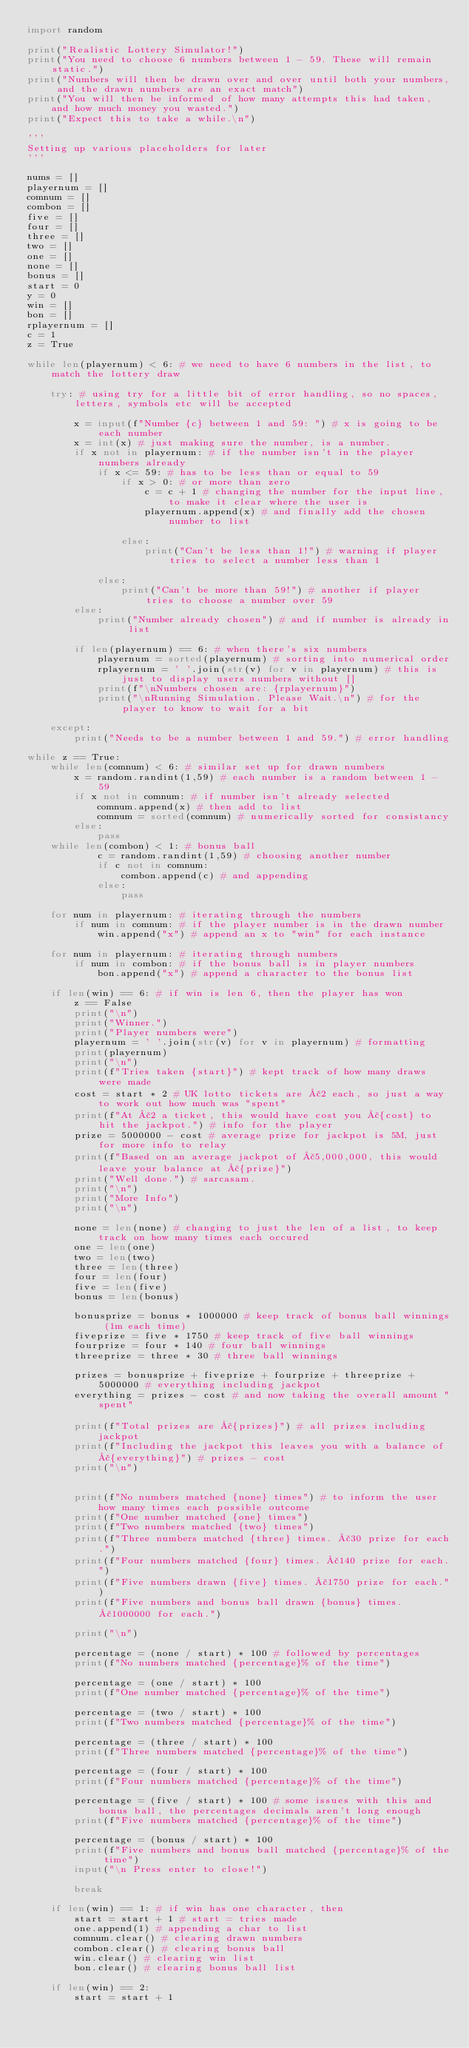<code> <loc_0><loc_0><loc_500><loc_500><_Python_>import random

print("Realistic Lottery Simulator!")
print("You need to choose 6 numbers between 1 - 59. These will remain static.")
print("Numbers will then be drawn over and over until both your numbers, and the drawn numbers are an exact match")
print("You will then be informed of how many attempts this had taken, and how much money you wasted.")
print("Expect this to take a while.\n")

'''
Setting up various placeholders for later
'''

nums = []
playernum = []
comnum = []
combon = []
five = []
four = []
three = []
two = []
one = []
none = []
bonus = []
start = 0
y = 0
win = []
bon = []
rplayernum = []
c = 1
z = True

while len(playernum) < 6: # we need to have 6 numbers in the list, to match the lottery draw
    
    try: # using try for a little bit of error handling, so no spaces, letters, symbols etc will be accepted

        x = input(f"Number {c} between 1 and 59: ") # x is going to be each number
        x = int(x) # just making sure the number, is a number.
        if x not in playernum: # if the number isn't in the player numbers already
            if x <= 59: # has to be less than or equal to 59
                if x > 0: # or more than zero
                    c = c + 1 # changing the number for the input line, to make it clear where the user is
                    playernum.append(x) # and finally add the chosen number to list

                else:
                    print("Can't be less than 1!") # warning if player tries to select a number less than 1

            else:
                print("Can't be more than 59!") # another if player tries to choose a number over 59
        else:
            print("Number already chosen") # and if number is already in list

        if len(playernum) == 6: # when there's six numbers
            playernum = sorted(playernum) # sorting into numerical order
            rplayernum = ' '.join(str(v) for v in playernum) # this is just to display users numbers without []
            print(f"\nNumbers chosen are: {rplayernum}")
            print("\nRunning Simulation. Please Wait.\n") # for the player to know to wait for a bit
            
    except:
        print("Needs to be a number between 1 and 59.") # error handling

while z == True:       
    while len(comnum) < 6: # similar set up for drawn numbers
        x = random.randint(1,59) # each number is a random between 1 - 59
        if x not in comnum: # if number isn't already selected
            comnum.append(x) # then add to list
            comnum = sorted(comnum) # numerically sorted for consistancy
        else:
            pass
    while len(combon) < 1: # bonus ball
            c = random.randint(1,59) # choosing another number
            if c not in comnum:
                combon.append(c) # and appending
            else:
                pass

    for num in playernum: # iterating through the numbers
        if num in comnum: # if the player number is in the drawn number
            win.append("x") # append an x to "win" for each instance
        
    for num in playernum: # iterating through numbers
        if num in combon: # if the bonus ball is in player numbers
            bon.append("x") # append a character to the bonus list
    
    if len(win) == 6: # if win is len 6, then the player has won
        z == False
        print("\n")
        print("Winner.")
        print("Player numbers were")
        playernum = ' '.join(str(v) for v in playernum) # formatting
        print(playernum)
        print("\n")
        print(f"Tries taken {start}") # kept track of how many draws were made
        cost = start * 2 # UK lotto tickets are £2 each, so just a way to work out how much was "spent"
        print(f"At £2 a ticket, this would have cost you £{cost} to hit the jackpot.") # info for the player
        prize = 5000000 - cost # average prize for jackpot is 5M, just for more info to relay
        print(f"Based on an average jackpot of £5,000,000, this would leave your balance at £{prize}")
        print("Well done.") # sarcasam.
        print("\n")
        print("More Info")
        print("\n")
        
        none = len(none) # changing to just the len of a list, to keep track on how many times each occured
        one = len(one)
        two = len(two)
        three = len(three)
        four = len(four)
        five = len(five)
        bonus = len(bonus)
        
        bonusprize = bonus * 1000000 # keep track of bonus ball winnings (1m each time)
        fiveprize = five * 1750 # keep track of five ball winnings
        fourprize = four * 140 # four ball winnings
        threeprize = three * 30 # three ball winnings
        
        prizes = bonusprize + fiveprize + fourprize + threeprize + 5000000 # everything including jackpot
        everything = prizes - cost # and now taking the overall amount "spent"
        
        print(f"Total prizes are £{prizes}") # all prizes including jackpot
        print(f"Including the jackpot this leaves you with a balance of £{everything}") # prizes - cost
        print("\n")
        
        
        print(f"No numbers matched {none} times") # to inform the user how many times each possible outcome
        print(f"One number matched {one} times")
        print(f"Two numbers matched {two} times")
        print(f"Three numbers matched {three} times. £30 prize for each.")
        print(f"Four numbers matched {four} times. £140 prize for each.")
        print(f"Five numbers drawn {five} times. £1750 prize for each.")
        print(f"Five numbers and bonus ball drawn {bonus} times. £1000000 for each.")
        
        print("\n")

        percentage = (none / start) * 100 # followed by percentages
        print(f"No numbers matched {percentage}% of the time")

        percentage = (one / start) * 100
        print(f"One number matched {percentage}% of the time")

        percentage = (two / start) * 100
        print(f"Two numbers matched {percentage}% of the time")

        percentage = (three / start) * 100
        print(f"Three numbers matched {percentage}% of the time")

        percentage = (four / start) * 100
        print(f"Four numbers matched {percentage}% of the time")

        percentage = (five / start) * 100 # some issues with this and bonus ball, the percentages decimals aren't long enough
        print(f"Five numbers matched {percentage}% of the time") 
        
        percentage = (bonus / start) * 100
        print(f"Five numbers and bonus ball matched {percentage}% of the time")
        input("\n Press enter to close!")
        
        break
        
    if len(win) == 1: # if win has one character, then
        start = start + 1 # start = tries made
        one.append(1) # appending a char to list
        comnum.clear() # clearing drawn numbers
        combon.clear() # clearing bonus ball
        win.clear() # clearing win list
        bon.clear() # clearing bonus ball list
        
    if len(win) == 2:
        start = start + 1</code> 